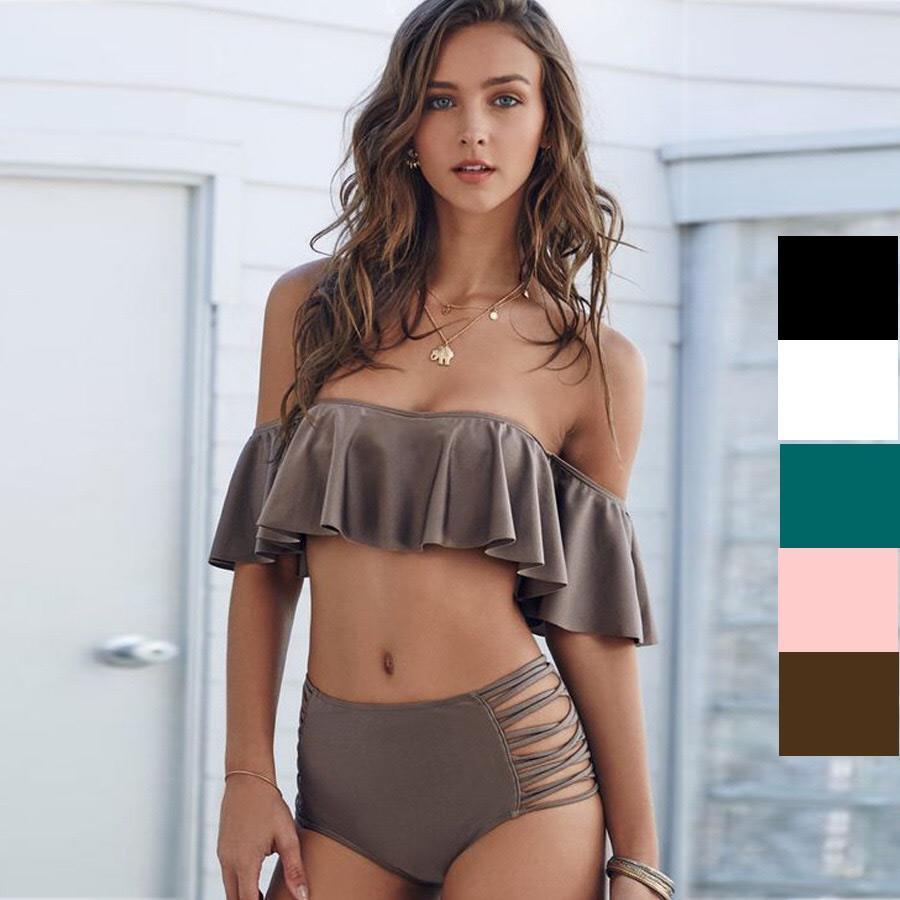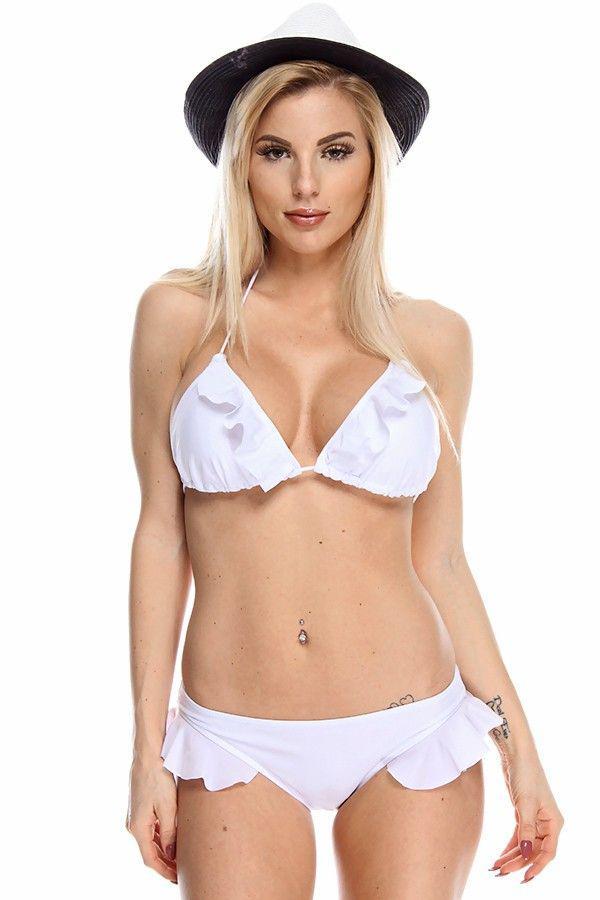The first image is the image on the left, the second image is the image on the right. For the images displayed, is the sentence "The swimsuit top in one image has a large ruffle that covers the bra and extends over the upper arms of the model." factually correct? Answer yes or no. Yes. 